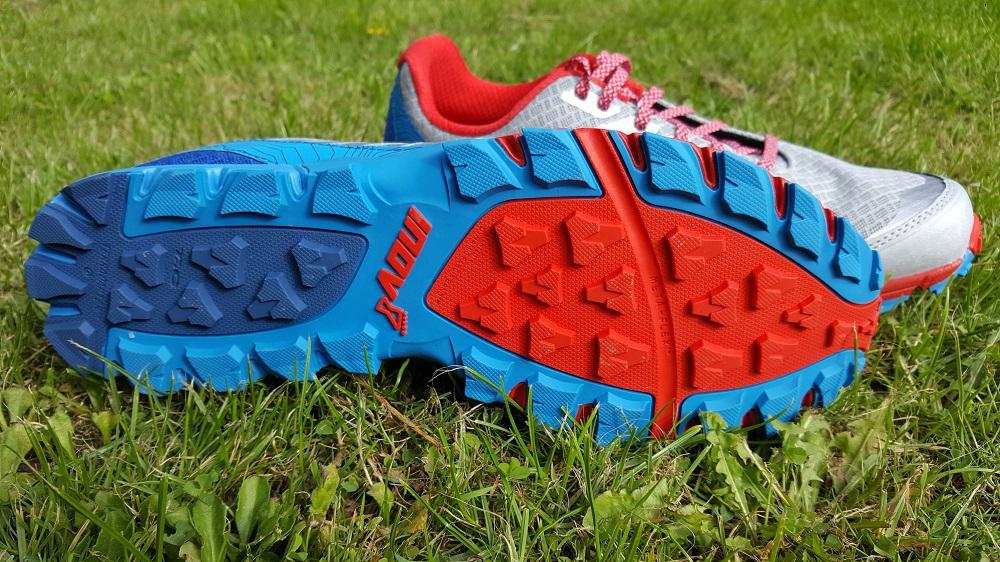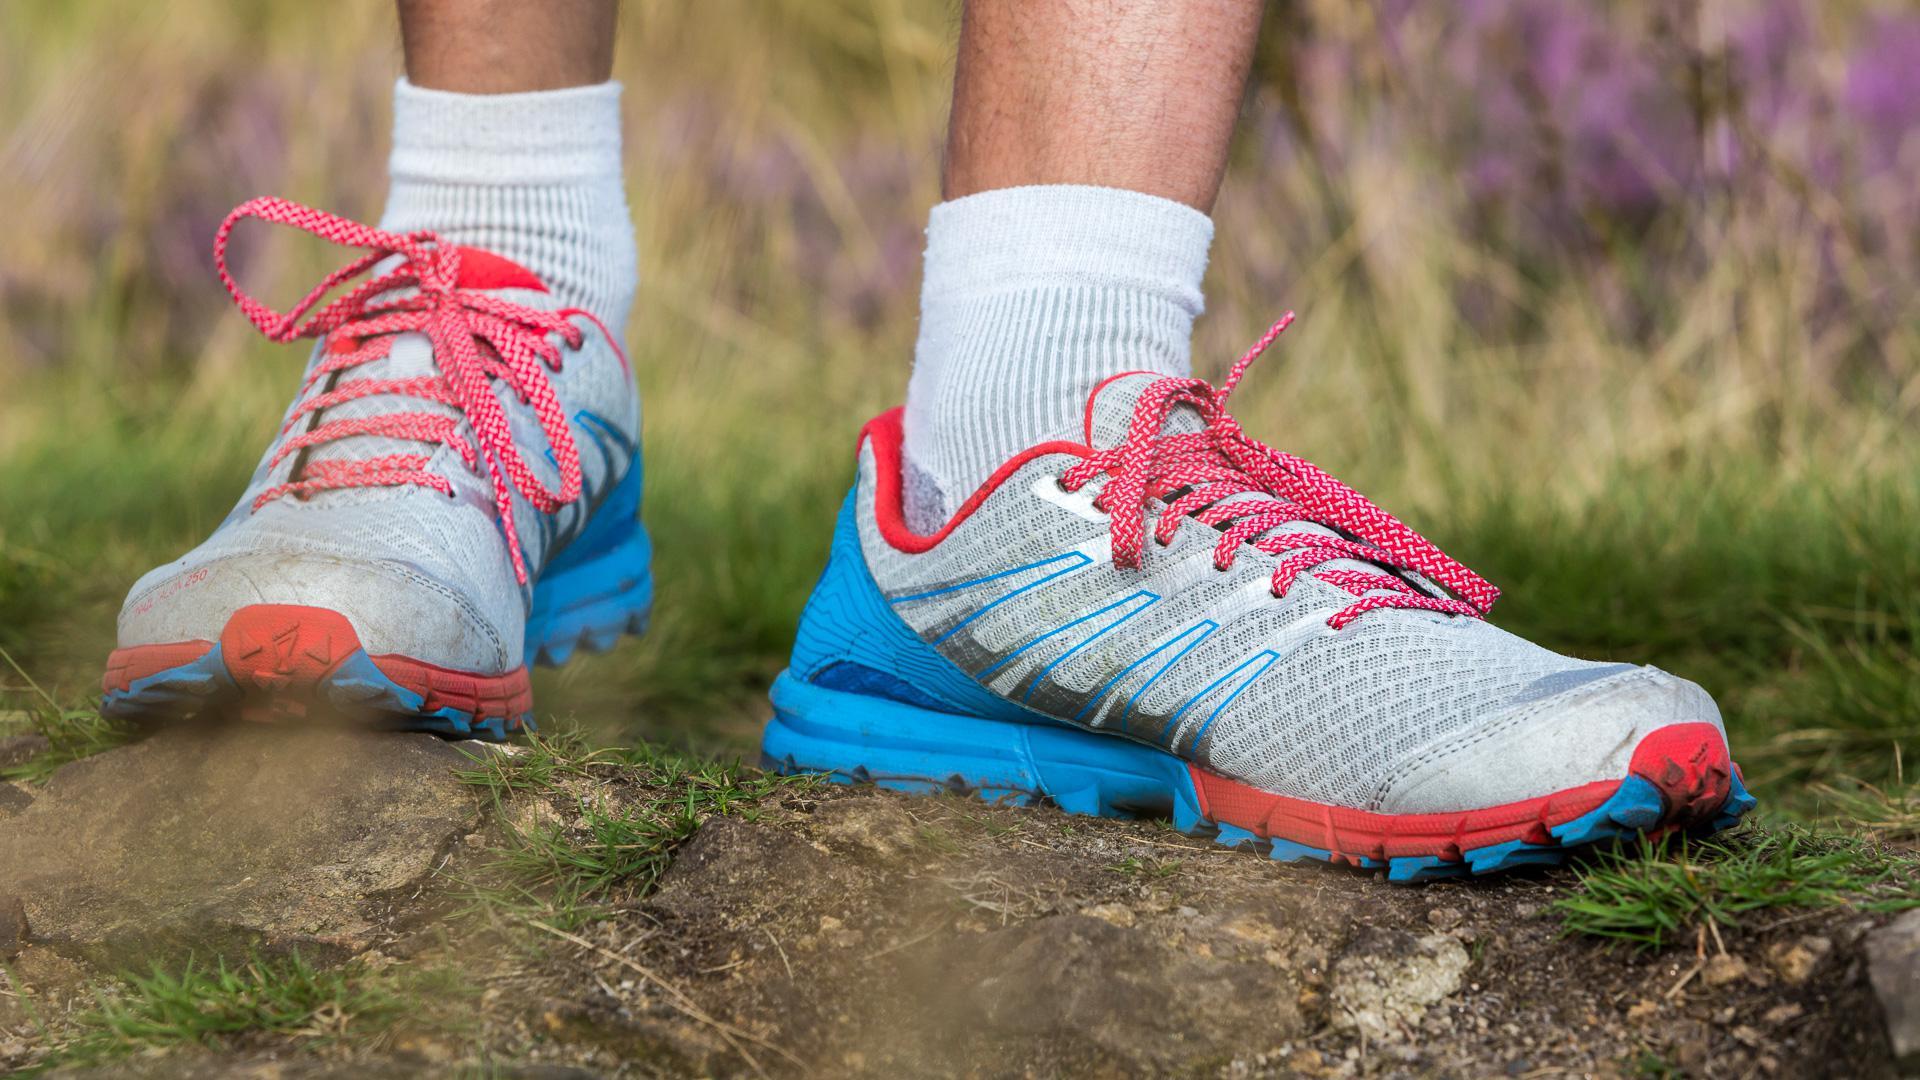The first image is the image on the left, the second image is the image on the right. Considering the images on both sides, is "An image shows the red and blue treaded sole of a sneaker." valid? Answer yes or no. Yes. The first image is the image on the left, the second image is the image on the right. Considering the images on both sides, is "One of the shoes in one of the images is turned on its side." valid? Answer yes or no. Yes. 